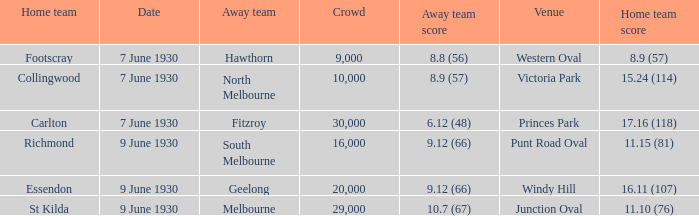What is the typical audience size for hawthorn when they play as the visiting team? 9000.0. 